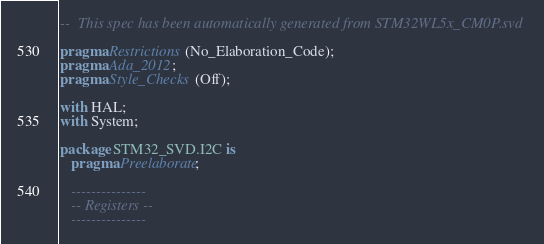<code> <loc_0><loc_0><loc_500><loc_500><_Ada_>--  This spec has been automatically generated from STM32WL5x_CM0P.svd

pragma Restrictions (No_Elaboration_Code);
pragma Ada_2012;
pragma Style_Checks (Off);

with HAL;
with System;

package STM32_SVD.I2C is
   pragma Preelaborate;

   ---------------
   -- Registers --
   ---------------
</code> 